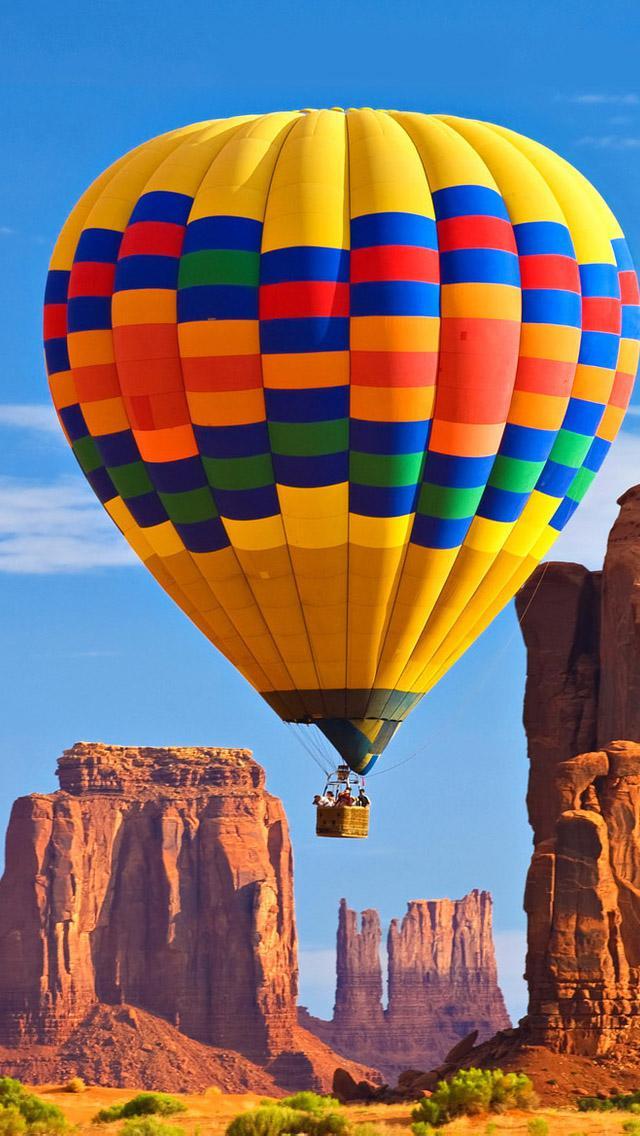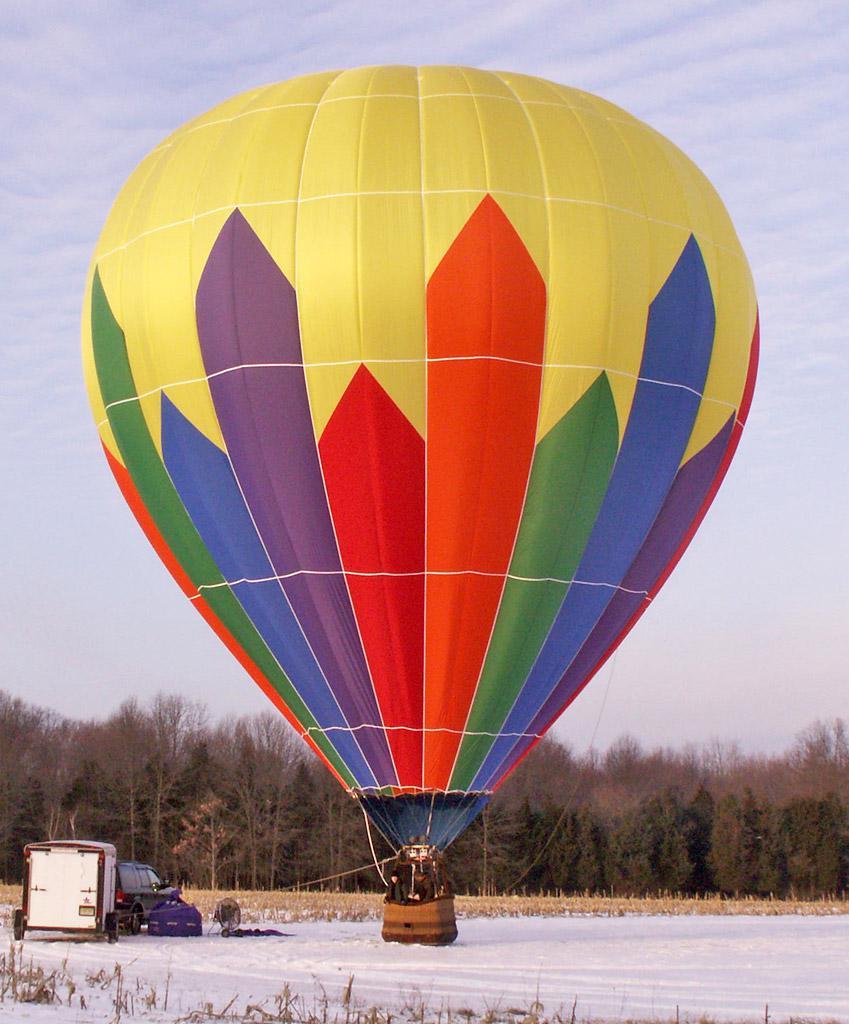The first image is the image on the left, the second image is the image on the right. Given the left and right images, does the statement "Left image shows a balloon with multi-colored squarish shapes." hold true? Answer yes or no. Yes. The first image is the image on the left, the second image is the image on the right. Evaluate the accuracy of this statement regarding the images: "One hot air balloon is sitting on a grassy area and one is floating in the air.". Is it true? Answer yes or no. No. 